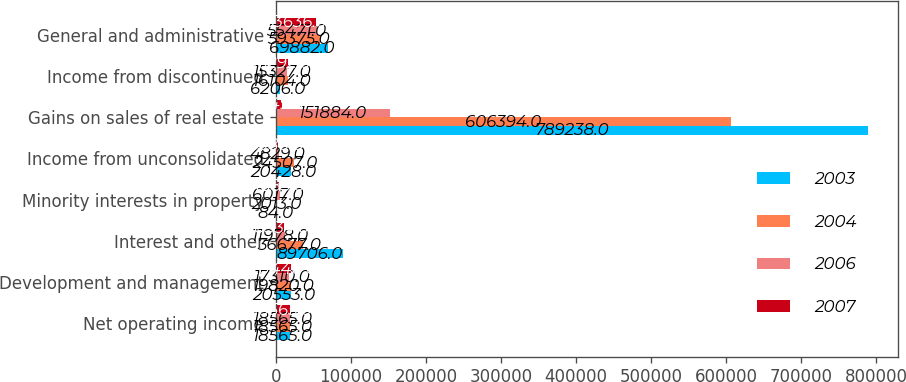Convert chart to OTSL. <chart><loc_0><loc_0><loc_500><loc_500><stacked_bar_chart><ecel><fcel>Net operating income<fcel>Development and management<fcel>Interest and other<fcel>Minority interests in property<fcel>Income from unconsolidated<fcel>Gains on sales of real estate<fcel>Income from discontinued<fcel>General and administrative<nl><fcel>2003<fcel>18565<fcel>20553<fcel>89706<fcel>84<fcel>20428<fcel>789238<fcel>6206<fcel>69882<nl><fcel>2004<fcel>18565<fcel>19820<fcel>36677<fcel>2013<fcel>24507<fcel>606394<fcel>16104<fcel>59375<nl><fcel>2006<fcel>18565<fcel>17310<fcel>11978<fcel>6017<fcel>4829<fcel>151884<fcel>15327<fcel>55471<nl><fcel>2007<fcel>18565<fcel>20440<fcel>10334<fcel>4685<fcel>3380<fcel>8149<fcel>16292<fcel>53636<nl></chart> 